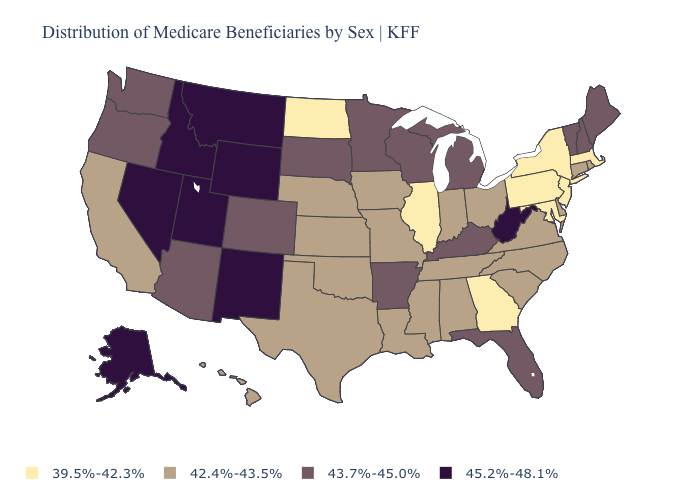Does Maine have the highest value in the Northeast?
Answer briefly. Yes. Among the states that border Wisconsin , which have the lowest value?
Short answer required. Illinois. What is the highest value in the USA?
Concise answer only. 45.2%-48.1%. What is the value of Alaska?
Concise answer only. 45.2%-48.1%. Which states have the highest value in the USA?
Concise answer only. Alaska, Idaho, Montana, Nevada, New Mexico, Utah, West Virginia, Wyoming. Which states have the lowest value in the USA?
Give a very brief answer. Georgia, Illinois, Maryland, Massachusetts, New Jersey, New York, North Dakota, Pennsylvania. Among the states that border West Virginia , which have the lowest value?
Concise answer only. Maryland, Pennsylvania. Which states have the lowest value in the MidWest?
Give a very brief answer. Illinois, North Dakota. Name the states that have a value in the range 39.5%-42.3%?
Answer briefly. Georgia, Illinois, Maryland, Massachusetts, New Jersey, New York, North Dakota, Pennsylvania. Does Nevada have the highest value in the USA?
Concise answer only. Yes. What is the value of Hawaii?
Keep it brief. 42.4%-43.5%. What is the value of Vermont?
Concise answer only. 43.7%-45.0%. What is the value of Montana?
Keep it brief. 45.2%-48.1%. Among the states that border Iowa , which have the lowest value?
Quick response, please. Illinois. What is the value of Arizona?
Concise answer only. 43.7%-45.0%. 